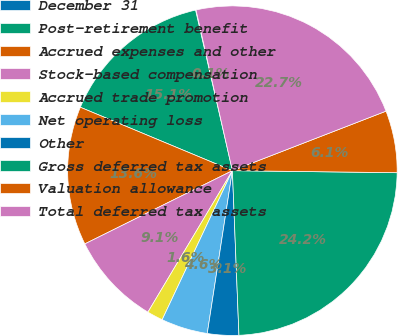<chart> <loc_0><loc_0><loc_500><loc_500><pie_chart><fcel>December 31<fcel>Post-retirement benefit<fcel>Accrued expenses and other<fcel>Stock-based compensation<fcel>Accrued trade promotion<fcel>Net operating loss<fcel>Other<fcel>Gross deferred tax assets<fcel>Valuation allowance<fcel>Total deferred tax assets<nl><fcel>0.05%<fcel>15.12%<fcel>13.62%<fcel>9.1%<fcel>1.56%<fcel>4.57%<fcel>3.07%<fcel>24.17%<fcel>6.08%<fcel>22.66%<nl></chart> 